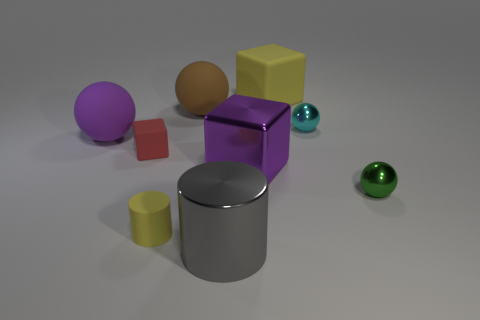Subtract all balls. How many objects are left? 5 Subtract 0 cyan blocks. How many objects are left? 9 Subtract all tiny yellow matte objects. Subtract all yellow rubber blocks. How many objects are left? 7 Add 8 yellow rubber things. How many yellow rubber things are left? 10 Add 7 big brown spheres. How many big brown spheres exist? 8 